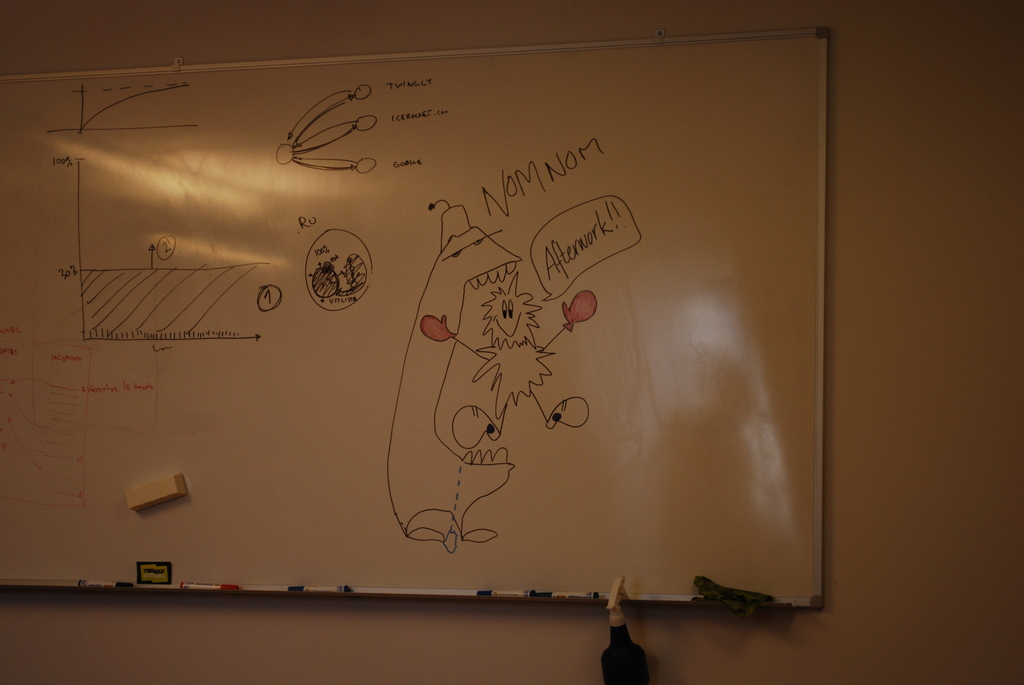Can you explain the cartoon figure drawn on the board? The cartoon figure is a humorous depiction, drawn with exaggerated features and expressions, saying 'Afterwork!' in a speech balloon labeled 'NOM NOM'. This drawing might be used to lighten the mood in what seems like a technical or scientific setting. Why might someone include such drawings in a work environment? Such drawings can serve as a creative outlet and add a touch of humor and personality to the workplace, helping to reduce stress and promote a more relaxed atmosphere among coworkers. 